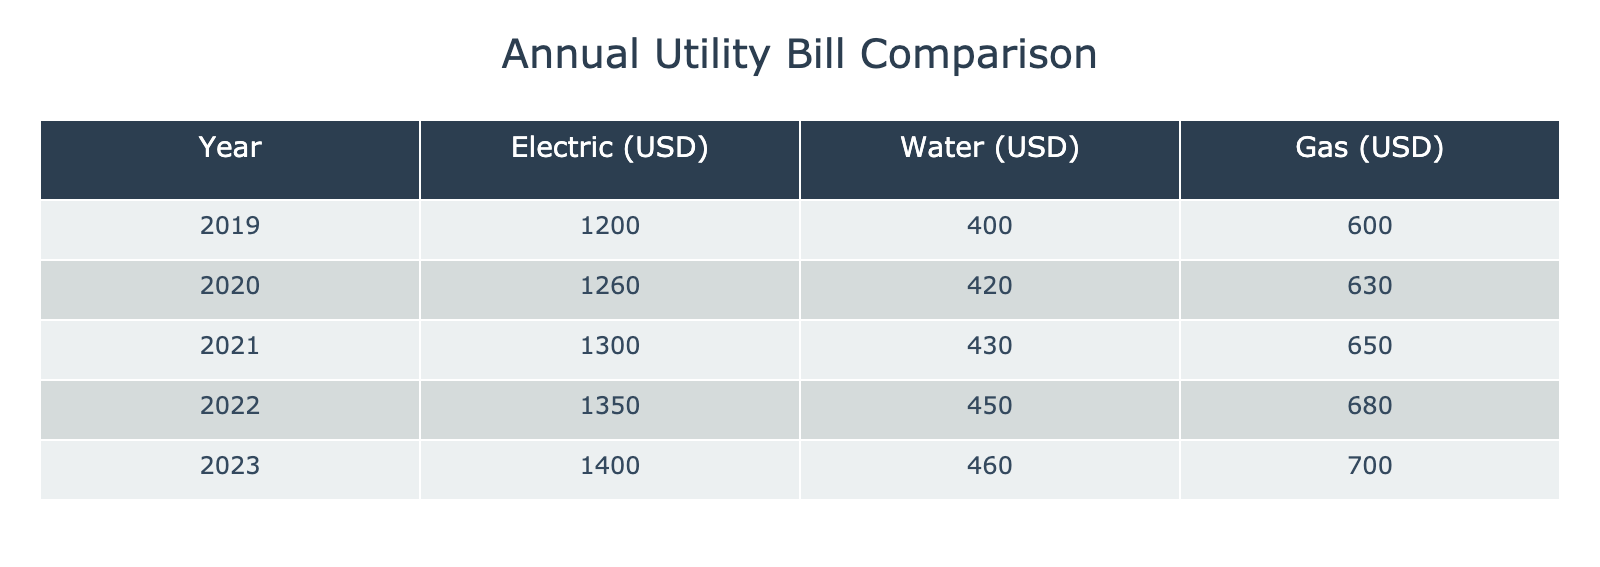What was the total electric bill for the year 2022? To find the total electric bill for the year 2022, we simply look at the corresponding value in the "Electric (USD)" column for the year 2022, which is 1350.
Answer: 1350 What was the annual water bill in 2020 compared to 2022? The water bill in 2020 was 420, and in 2022 it was 450. To compare them, we can say 450 - 420 = 30. Therefore, the water bill in 2022 was 30 USD higher than in 2020.
Answer: 30 Has the total gas bill decreased from 2019 to 2021? In 2019, the gas bill was 600, and in 2021 it was 650. Since 650 is greater than 600, the total gas bill has not decreased; it has actually increased.
Answer: No What is the average annual utility cost for gas over the years presented? To find the average annual utility cost for gas, we need the values for gas from 2019 to 2023: 600, 630, 650, 680, and 700. Summing these values gives us 3360, and since there are 5 years, we divide by 5: 3360 / 5 = 672.
Answer: 672 In which year did the electric bill see the largest increase compared to the previous year? We compare the yearly increases in the electric bill: 2020 - 2019: 1260 - 1200 = 60, 2021 - 2020: 1300 - 1260 = 40, 2022 - 2021: 1350 - 1300 = 50, and 2023 - 2022: 1400 - 1350 = 50. The largest increase was 60 USD from 2019 to 2020.
Answer: 2019 to 2020 Did the total utility bills across all categories increase every year? We need to calculate the total utility bills for each year. For example, 2019: 1200 + 400 + 600 = 2200; 2020: 1260 + 420 + 630 = 2310; continuing this way confirms that each year sees an increase: 2019 to 2020 is an increase of 110, 2020 to 2021 is an increase of 90, and so on till 2023. Hence, the total utility bills did increase every year.
Answer: Yes 